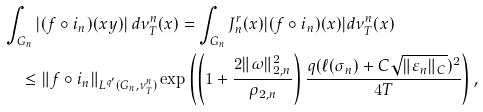<formula> <loc_0><loc_0><loc_500><loc_500>& \int _ { G _ { n } } | ( f \circ i _ { n } ) ( x y ) | \, d \nu _ { T } ^ { n } ( x ) = \int _ { G _ { n } } J _ { n } ^ { r } ( x ) | ( f \circ i _ { n } ) ( x ) | d \nu _ { T } ^ { n } ( x ) \\ & \quad \leq \| f \circ i _ { n } \| _ { L ^ { q ^ { \prime } } ( G _ { n } , \nu _ { T } ^ { n } ) } \exp \left ( \left ( 1 + \frac { 2 \| \omega \| _ { 2 , n } ^ { 2 } } { \rho _ { 2 , n } } \right ) \frac { q ( \ell ( \sigma _ { n } ) + C \sqrt { \| \varepsilon _ { n } \| _ { C } } ) ^ { 2 } } { 4 T } \right ) ,</formula> 